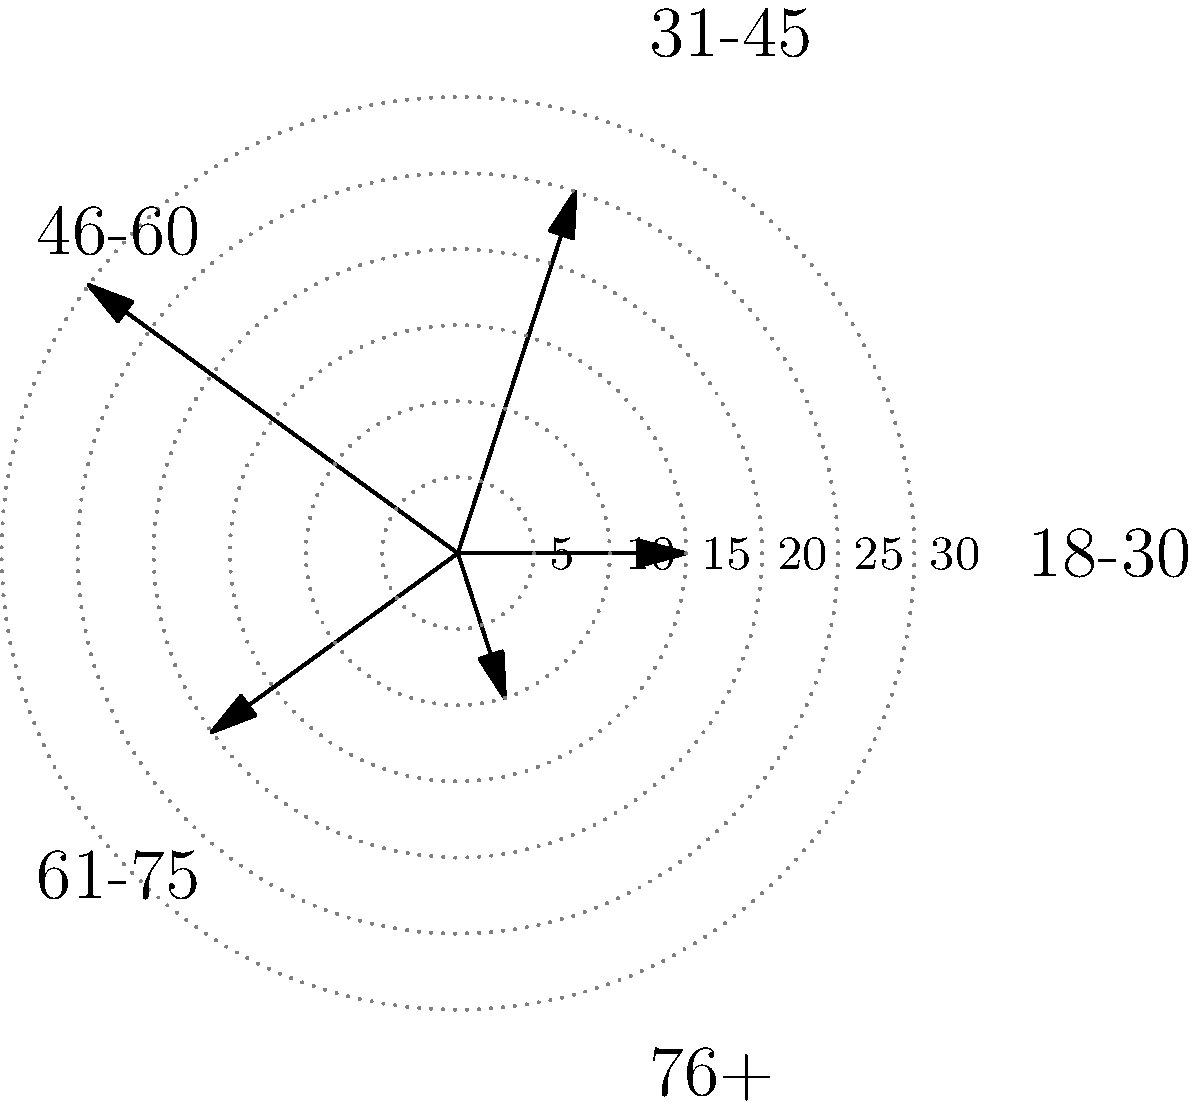In the polar rose diagram representing age demographics of documentary viewers, which age group shows the highest viewership percentage? To determine the age group with the highest viewership percentage, we need to analyze the polar rose diagram:

1. The diagram displays five age groups: 18-30, 31-45, 46-60, 61-75, and 76+.
2. Each group is represented by a "petal" of the rose, with the length of the petal indicating the viewership percentage.
3. The concentric dotted circles represent percentage increments of 5%.
4. By visually comparing the lengths of the petals:
   - 18-30: extends to about 15%
   - 31-45: extends to about 25%
   - 46-60: extends to about 30%
   - 61-75: extends to about 20%
   - 76+: extends to about 10%
5. The longest petal corresponds to the 46-60 age group, reaching approximately 30%.

Therefore, the age group with the highest viewership percentage is 46-60.
Answer: 46-60 